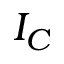Convert formula to latex. <formula><loc_0><loc_0><loc_500><loc_500>I _ { C }</formula> 